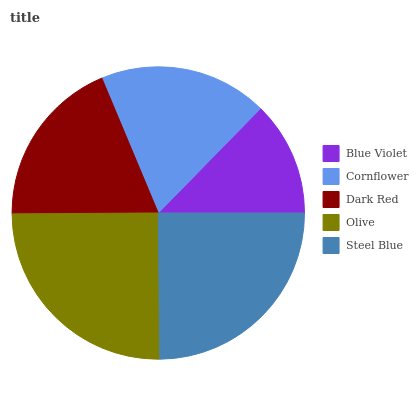Is Blue Violet the minimum?
Answer yes or no. Yes. Is Olive the maximum?
Answer yes or no. Yes. Is Cornflower the minimum?
Answer yes or no. No. Is Cornflower the maximum?
Answer yes or no. No. Is Cornflower greater than Blue Violet?
Answer yes or no. Yes. Is Blue Violet less than Cornflower?
Answer yes or no. Yes. Is Blue Violet greater than Cornflower?
Answer yes or no. No. Is Cornflower less than Blue Violet?
Answer yes or no. No. Is Dark Red the high median?
Answer yes or no. Yes. Is Dark Red the low median?
Answer yes or no. Yes. Is Blue Violet the high median?
Answer yes or no. No. Is Blue Violet the low median?
Answer yes or no. No. 